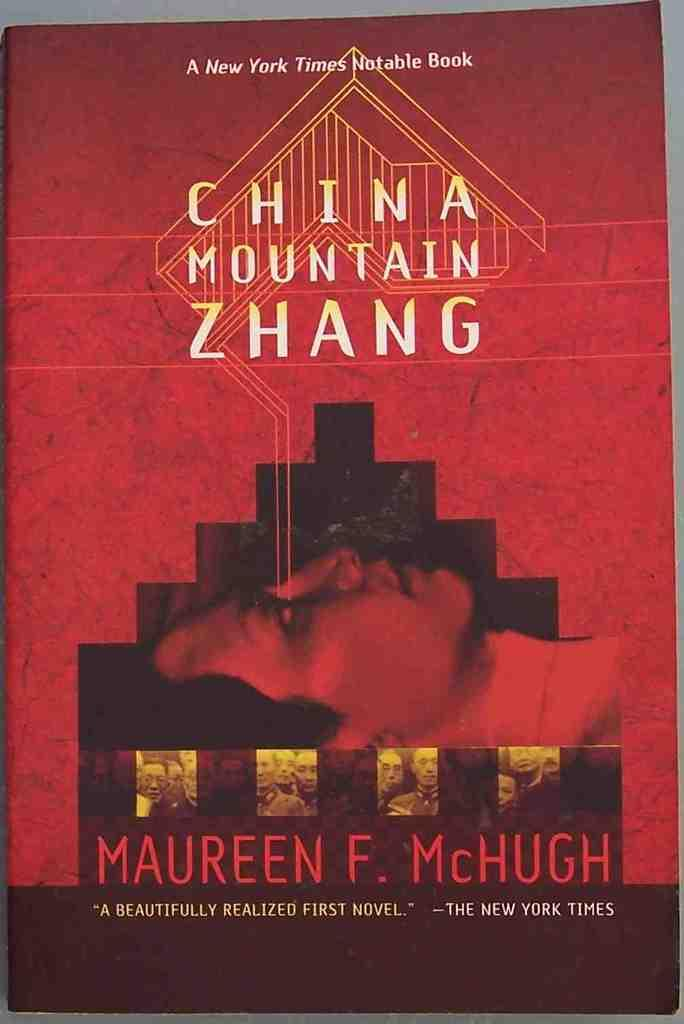What is the main subject of the image? The main subject of the image is the cover page of a book. What can be seen on the cover page of the book? There is text on the book in the image. Where is the quiver located in the image? There is no quiver present in the image. What type of umbrella is shown on the cover page of the book? There is no umbrella present on the cover page of the book in the image. 